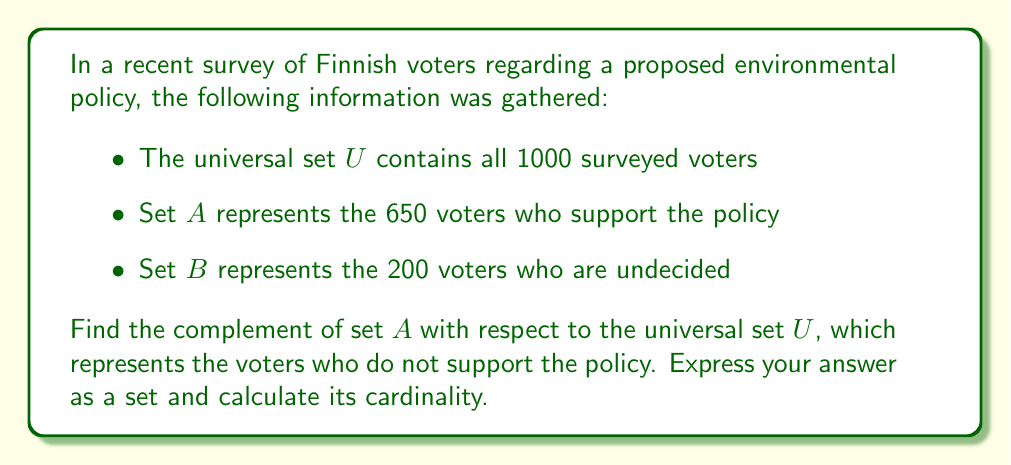Give your solution to this math problem. To solve this problem, we need to follow these steps:

1) First, let's define the complement of set $A$:
   The complement of $A$, denoted as $A^c$ or $\overline{A}$, is the set of all elements in the universal set $U$ that are not in $A$.

2) We can express this mathematically as:
   $A^c = U \setminus A$

3) We know that:
   - $|U| = 1000$ (total number of surveyed voters)
   - $|A| = 650$ (number of voters supporting the policy)
   - $|B| = 200$ (number of undecided voters)

4) The complement of $A$ will include both the undecided voters and those who oppose the policy.

5) To find the cardinality of $A^c$, we can subtract the number of elements in $A$ from the total number of elements in $U$:

   $|A^c| = |U| - |A| = 1000 - 650 = 350$

6) Therefore, the set $A^c$ represents 350 voters who do not support the policy.

7) We can express $A^c$ as a set:
   $A^c = \{x \in U : x \notin A\}$
Answer: $A^c = \{x \in U : x \notin A\}$, where $|A^c| = 350$ 